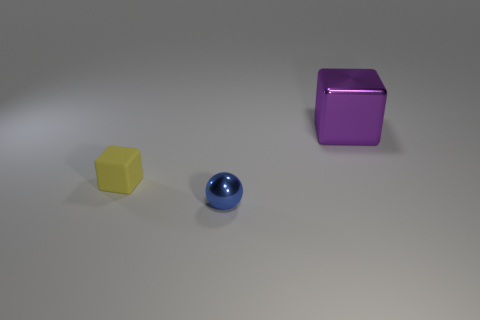Is there anything else that has the same shape as the small blue metal thing?
Keep it short and to the point. No. What number of shiny things are small objects or large purple cubes?
Provide a short and direct response. 2. There is a cube on the right side of the metal object on the left side of the purple metal thing; what is it made of?
Provide a succinct answer. Metal. The matte block has what color?
Provide a short and direct response. Yellow. Is there a small yellow block behind the small object that is on the left side of the blue sphere?
Offer a very short reply. No. What is the sphere made of?
Offer a very short reply. Metal. Is the small block on the left side of the blue ball made of the same material as the object that is on the right side of the tiny metal sphere?
Offer a very short reply. No. Is there anything else that has the same color as the small matte cube?
Offer a very short reply. No. What is the color of the other rubber thing that is the same shape as the purple thing?
Offer a terse response. Yellow. How big is the thing that is to the right of the tiny yellow matte block and behind the metal sphere?
Offer a terse response. Large. 